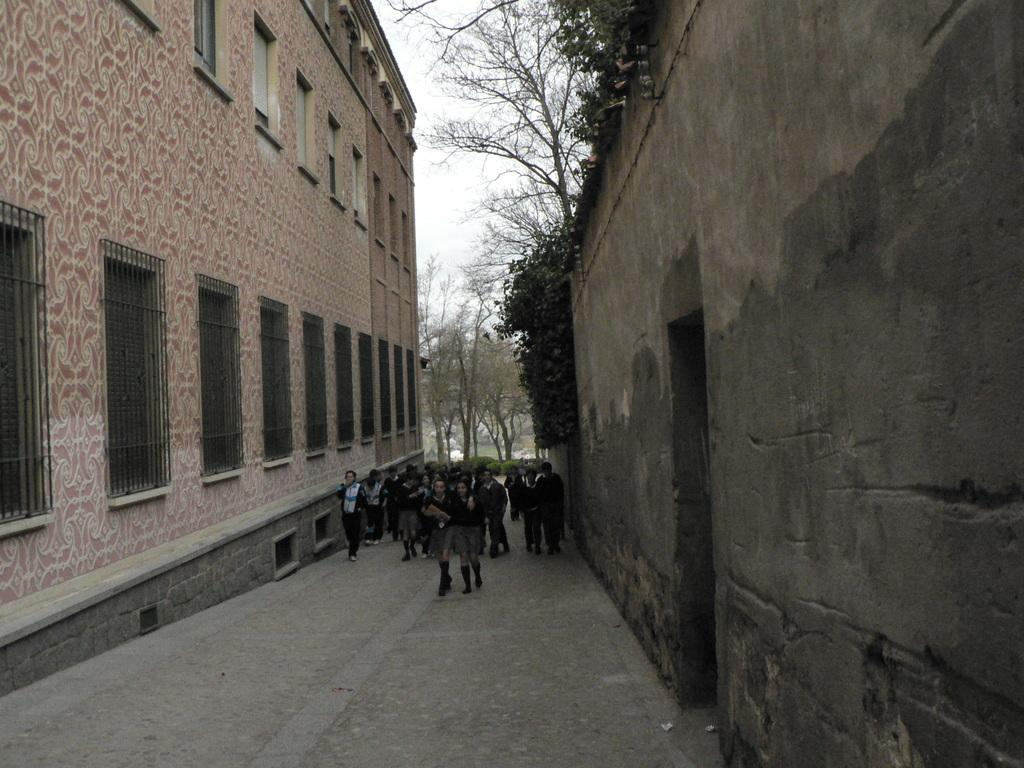What is the main feature of the image? There is a road in the image. What are the children doing on the road? Children are walking on the road. What can be seen on either side of the road? There are buildings on either side of the road. What is visible in the background of the image? Trees are visible in the background of the image. What type of creature is hiding in the cellar in the image? There is no cellar or creature present in the image. 